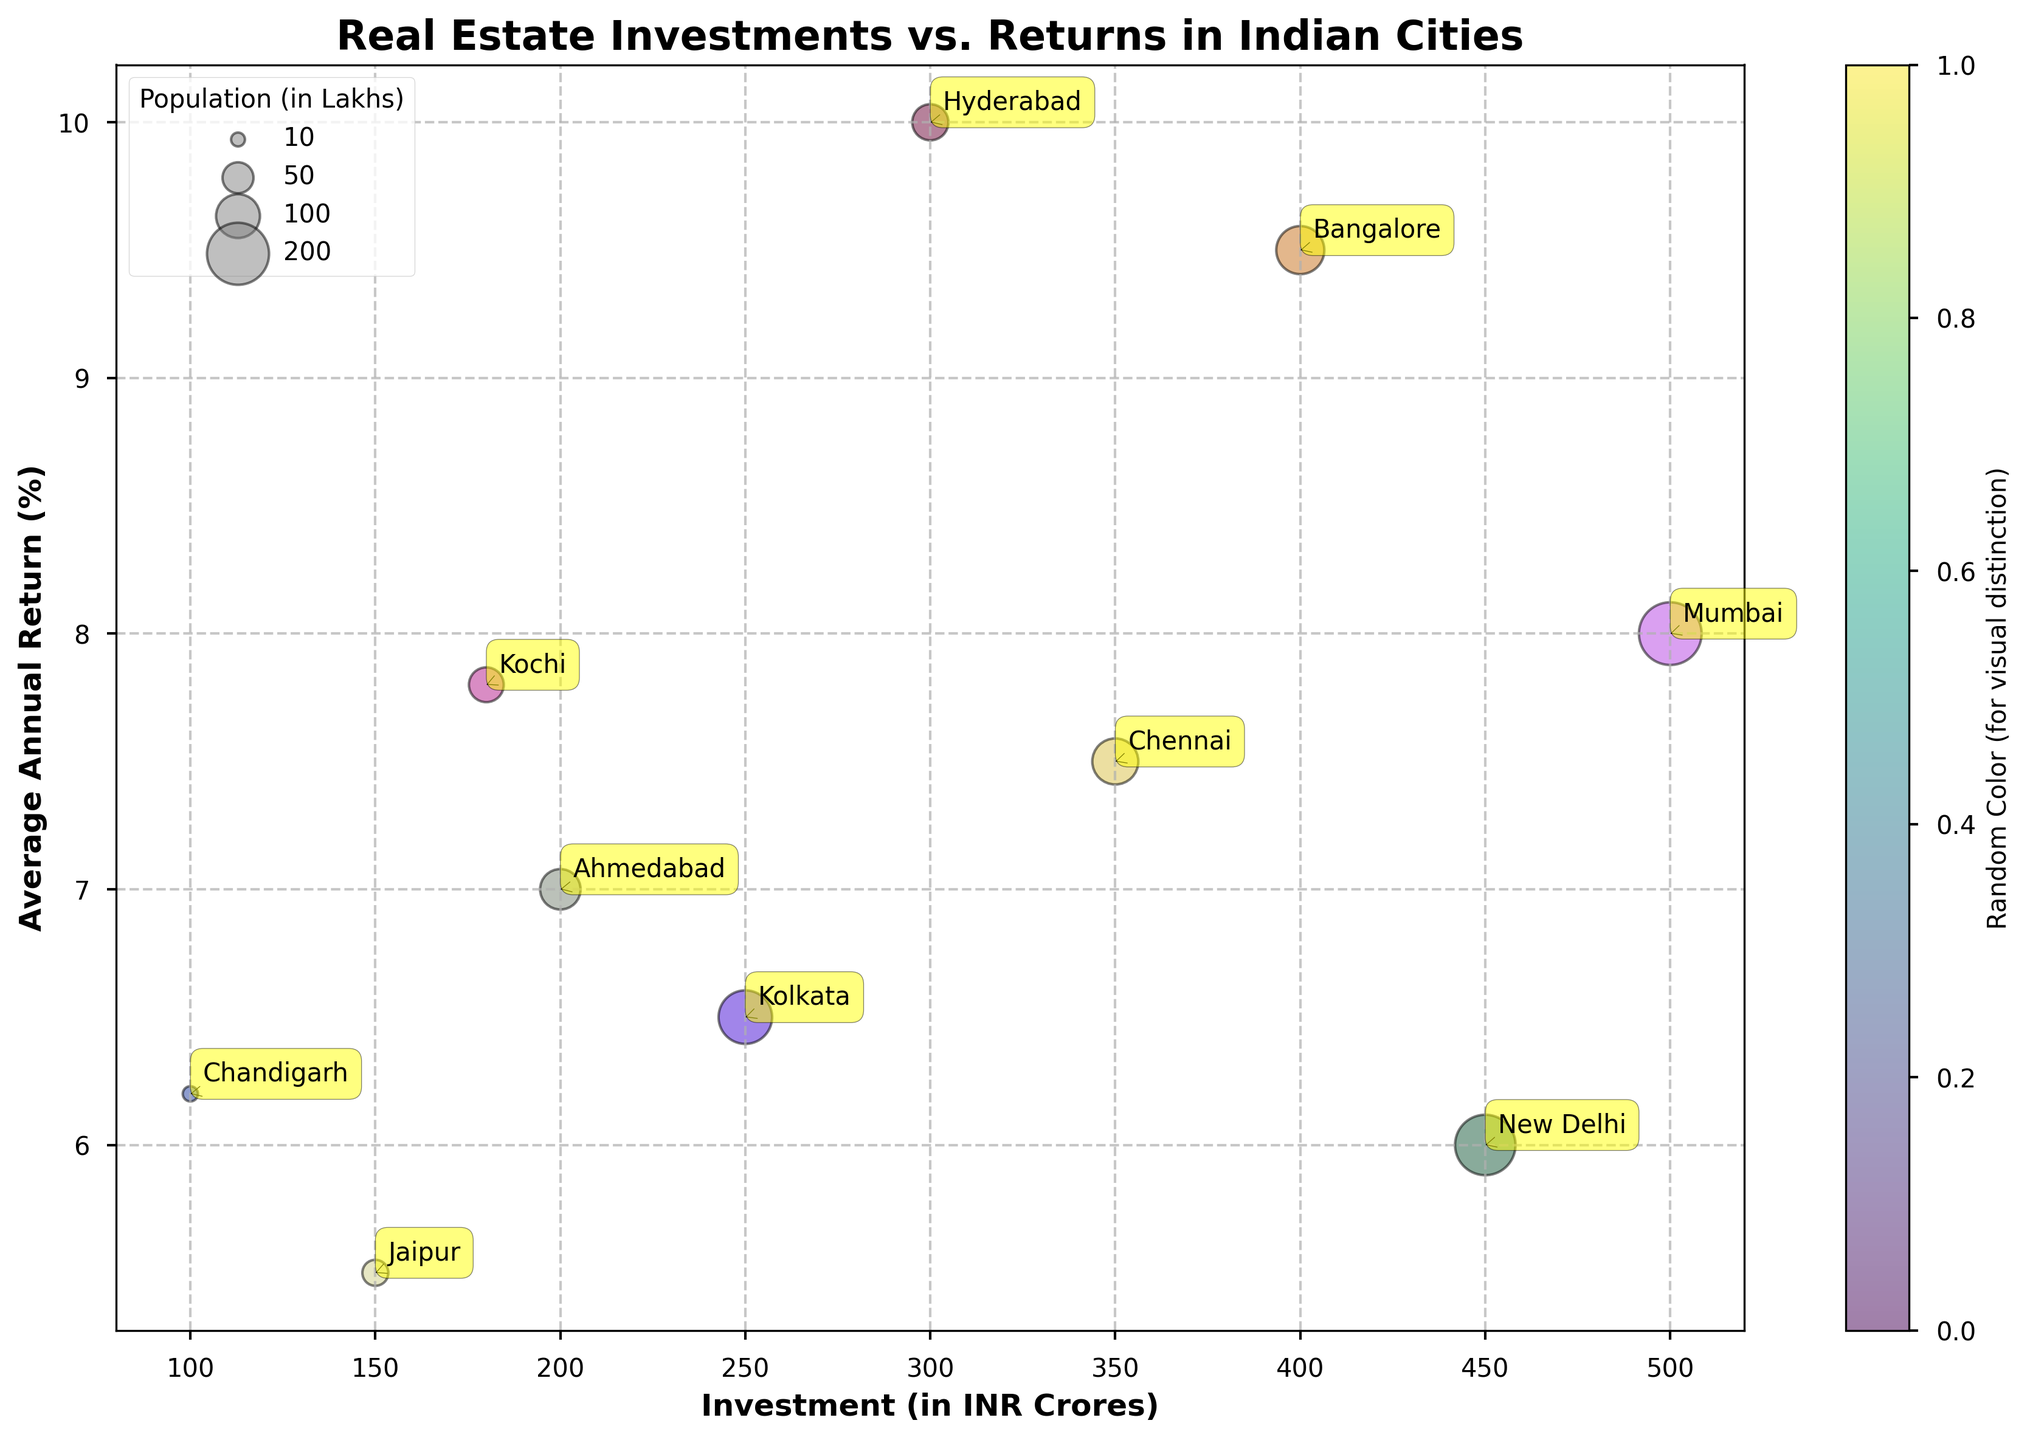What is the title of the figure? The title of the figure is usually displayed at the top, in boldface text. In this specific case, look at the top of the plot where "Real Estate Investments vs. Returns in Indian Cities" is written in bold.
Answer: Real Estate Investments vs. Returns in Indian Cities Which city has the highest average annual return? Scan the y-axis (representing the Average Annual Return %) for the highest value and look horizontally across to see which city is labeled. The highest point on the y-axis corresponds to Hyderabad, which is labeled with the highest return value of 10.0%.
Answer: Hyderabad Among Mumbai and New Delhi, which city has a higher investment? Locate Mumbai and New Delhi on the x-axis (Investment in INR Crores). Compare their positions on the x-axis. Mumbai is at 500 INR Crores, and New Delhi is at 450 INR Crores. Thus, Mumbai has a higher investment.
Answer: Mumbai What city's bubble has the largest area and what does this signify? The size of the bubble correlates with the population. Look for the largest bubble in terms of area which is labeled as Mumbai, indicating it has the highest population among the cities shown.
Answer: Mumbai How does the average annual return of Chennai and Kochi compare? Identify the position of Chennai and Kochi on the y-axis. Chennai is positioned at 7.5% while Kochi is at 7.8%. Hence, Kochi has a slightly higher average annual return.
Answer: Kochi Which city has the lowest average annual return and what is this percentage? Scan the y-axis for the lowest value and look horizontally to find the corresponding city. The city at the lowest point is New Delhi, with an average annual return of 6.0%.
Answer: New Delhi Can you list the cities in descending order of their investments? Read the x-axis values for each city and sort them accordingly: Mumbai (500 INR Crores), New Delhi (450 INR Crores), Bangalore (400 INR Crores), Chennai (350 INR Crores), Hyderabad (300 INR Crores), Kolkata (250 INR Crores), Ahmedabad (200 INR Crores), Kochi (180 INR Crores), Jaipur (150 INR Crores), Chandigarh (100 INR Crores).
Answer: Mumbai > New Delhi > Bangalore > Chennai > Hyderabad > Kolkata > Ahmedabad > Kochi > Jaipur > Chandigarh How does the population of Hyderabad compare to that of Bangalore? Compare the size of the bubbles since the area of the bubble relates to population. Hyderabad's bubble is smaller than Bangalore's, suggesting Hyderabad has a lower population.
Answer: Hyderabad has a lower population What is the difference in investment between the city with the highest and the lowest investments? Identify cities with the highest (Mumbai) and lowest (Chandigarh) investments on the x-axis. Subtract Chandigarh's investment (100 INR Crores) from Mumbai's investment (500 INR Crores). The difference is 400 INR Crores.
Answer: 400 INR Crores Which city has a population closer to 100 lakhs? Look at the bubble sizes since they represent populations and compare them to find the one closest to 100 lakhs. Ahmedabad, with a population of 85 lakhs, is nearest to 100 lakhs.
Answer: Ahmedabad 